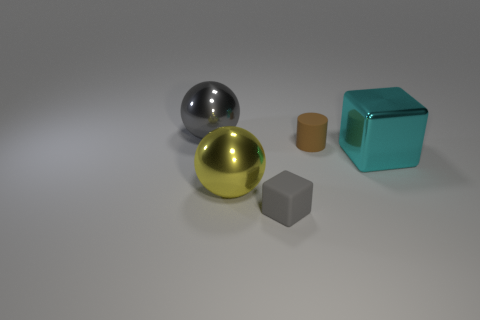Add 1 gray rubber objects. How many objects exist? 6 Subtract all cubes. How many objects are left? 3 Subtract 0 cyan balls. How many objects are left? 5 Subtract all big cyan objects. Subtract all gray rubber objects. How many objects are left? 3 Add 5 gray cubes. How many gray cubes are left? 6 Add 4 small brown matte things. How many small brown matte things exist? 5 